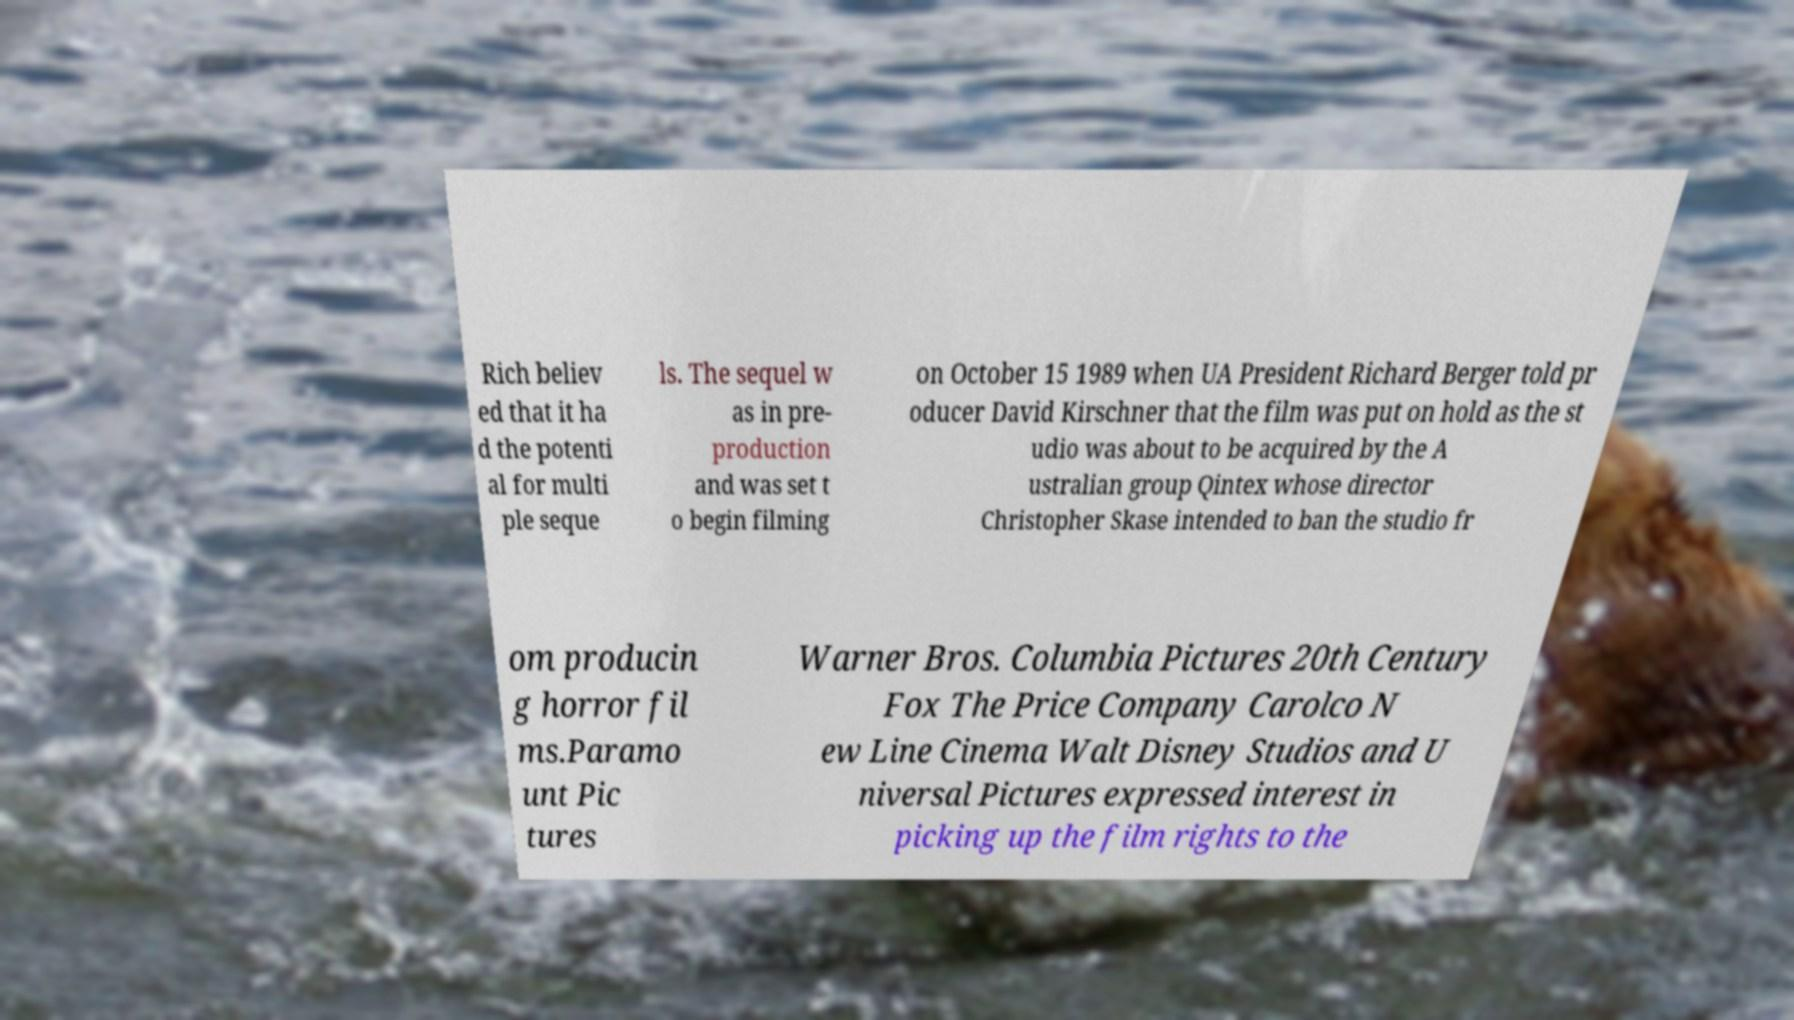Could you assist in decoding the text presented in this image and type it out clearly? Rich believ ed that it ha d the potenti al for multi ple seque ls. The sequel w as in pre- production and was set t o begin filming on October 15 1989 when UA President Richard Berger told pr oducer David Kirschner that the film was put on hold as the st udio was about to be acquired by the A ustralian group Qintex whose director Christopher Skase intended to ban the studio fr om producin g horror fil ms.Paramo unt Pic tures Warner Bros. Columbia Pictures 20th Century Fox The Price Company Carolco N ew Line Cinema Walt Disney Studios and U niversal Pictures expressed interest in picking up the film rights to the 